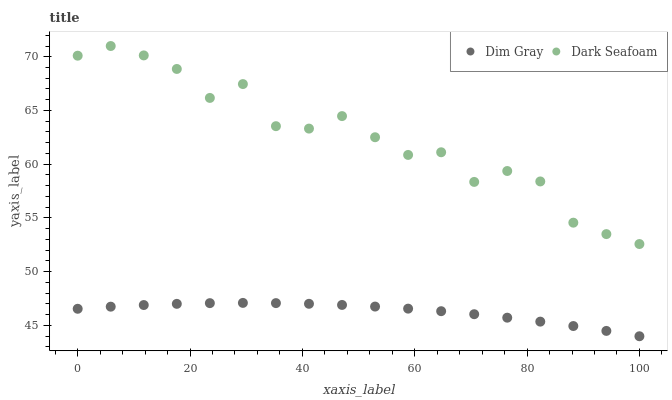Does Dim Gray have the minimum area under the curve?
Answer yes or no. Yes. Does Dark Seafoam have the maximum area under the curve?
Answer yes or no. Yes. Does Dim Gray have the maximum area under the curve?
Answer yes or no. No. Is Dim Gray the smoothest?
Answer yes or no. Yes. Is Dark Seafoam the roughest?
Answer yes or no. Yes. Is Dim Gray the roughest?
Answer yes or no. No. Does Dim Gray have the lowest value?
Answer yes or no. Yes. Does Dark Seafoam have the highest value?
Answer yes or no. Yes. Does Dim Gray have the highest value?
Answer yes or no. No. Is Dim Gray less than Dark Seafoam?
Answer yes or no. Yes. Is Dark Seafoam greater than Dim Gray?
Answer yes or no. Yes. Does Dim Gray intersect Dark Seafoam?
Answer yes or no. No. 